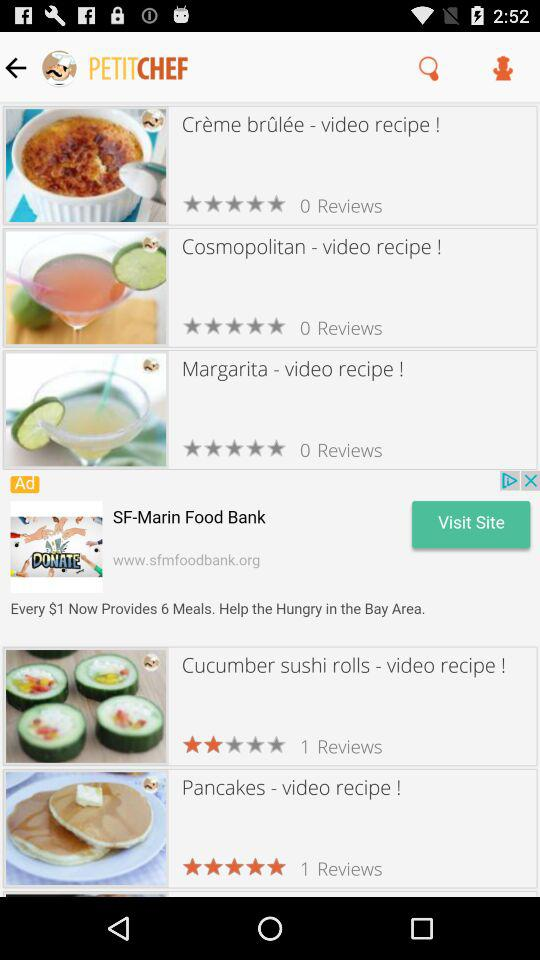What is the rating for "Cucumber sushi rolls"? The rating is 2 stars. 